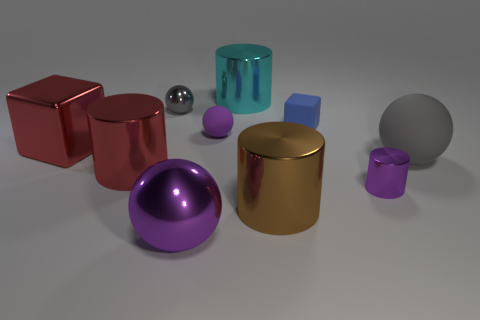If I were to organize these objects by size, which would be the largest and which would be the smallest? If we were to organize the objects by size, the largest would be the red metallic cube, given its volumetric presence in the image, while the smallest object appears to be the tiny silver sphere located near the center of the composition. 